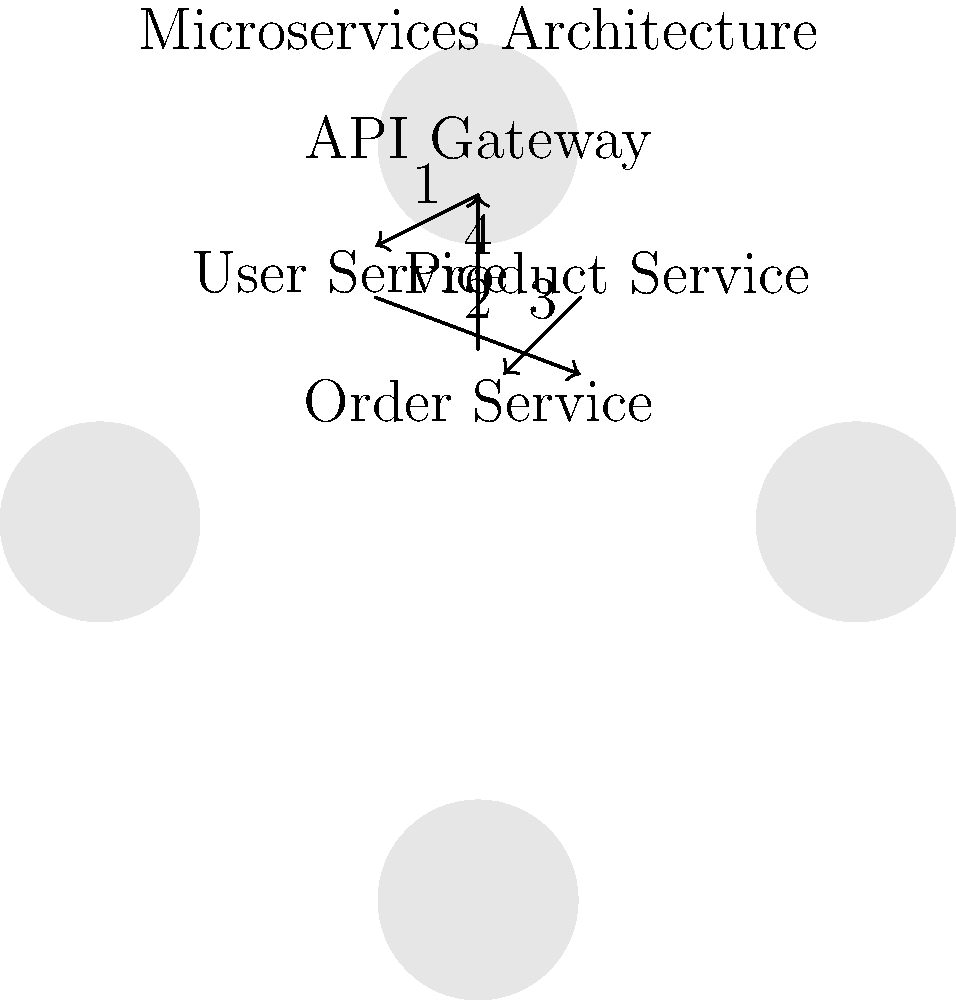In the given microservices architecture diagram, which service is responsible for orchestrating the communication between different services and acts as the entry point for client requests? To answer this question, let's analyze the diagram step-by-step:

1. The diagram shows four distinct services: API Gateway, User Service, Product Service, and Order Service.

2. The arrows indicate the flow of communication between these services.

3. Notice that all the arrows either start from or end at the topmost service, labeled "API Gateway".

4. In a microservices architecture, the API Gateway serves as the single entry point for all client requests. It's responsible for routing requests to the appropriate microservices, aggregating responses, and handling cross-cutting concerns like authentication and rate limiting.

5. The diagram shows the API Gateway communicating with all other services:
   - It sends a request to the User Service (arrow 1)
   - The User Service then communicates with the Order Service (arrow 2)
   - The Product Service also communicates with the Order Service (arrow 3)
   - Finally, the Order Service sends a response back to the API Gateway (arrow 4)

6. This flow demonstrates that the API Gateway is orchestrating the entire process, from receiving the initial request to returning the final response to the client.

Therefore, based on its central position in the diagram and its role in microservices architecture, the API Gateway is the service responsible for orchestrating communication and acting as the entry point for client requests.
Answer: API Gateway 